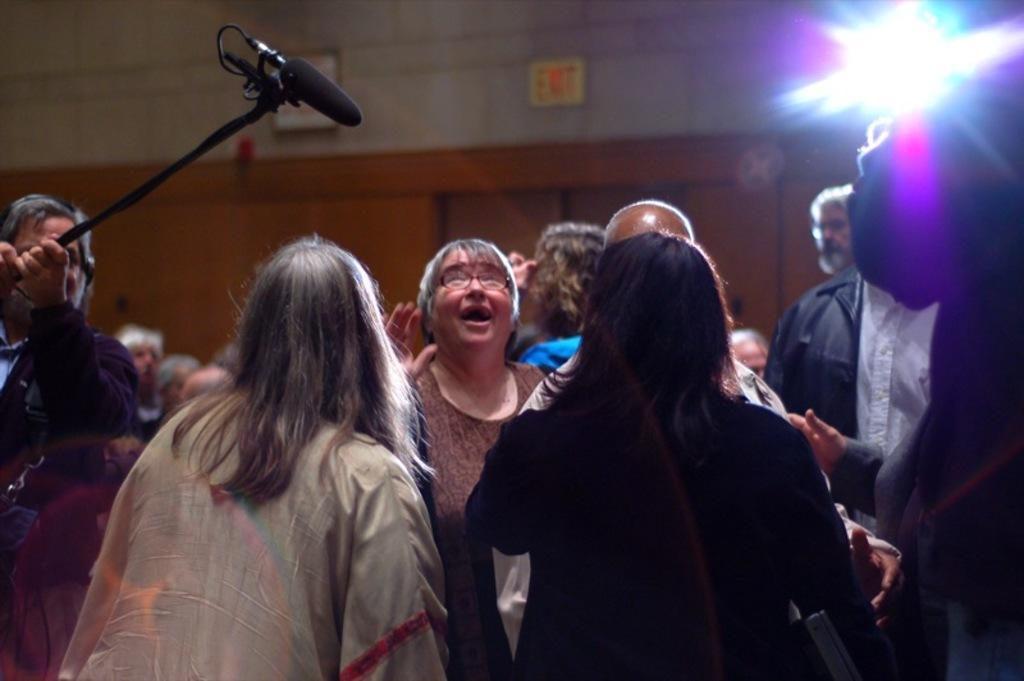Describe this image in one or two sentences. Group of people standing and left side of the image this person holding a microphone with stand. Background we can see light and boards on a wall. 